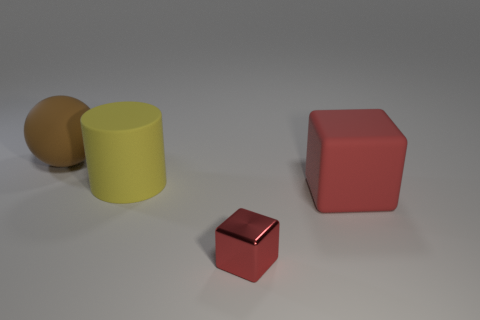Can you describe the arrangement of the objects? Certainly, the objects are arranged with a clear separation from one another. Starting from left to right, there’s a large brown sphere slightly touching a yellow cylinder, a small red cube, and a larger red cube. Do the objects have anything in common? Despite their differences in shape and size, all objects have a matte surface and are placed on the same flat surface, indicating a shared context, likely for a study on geometry or color. 